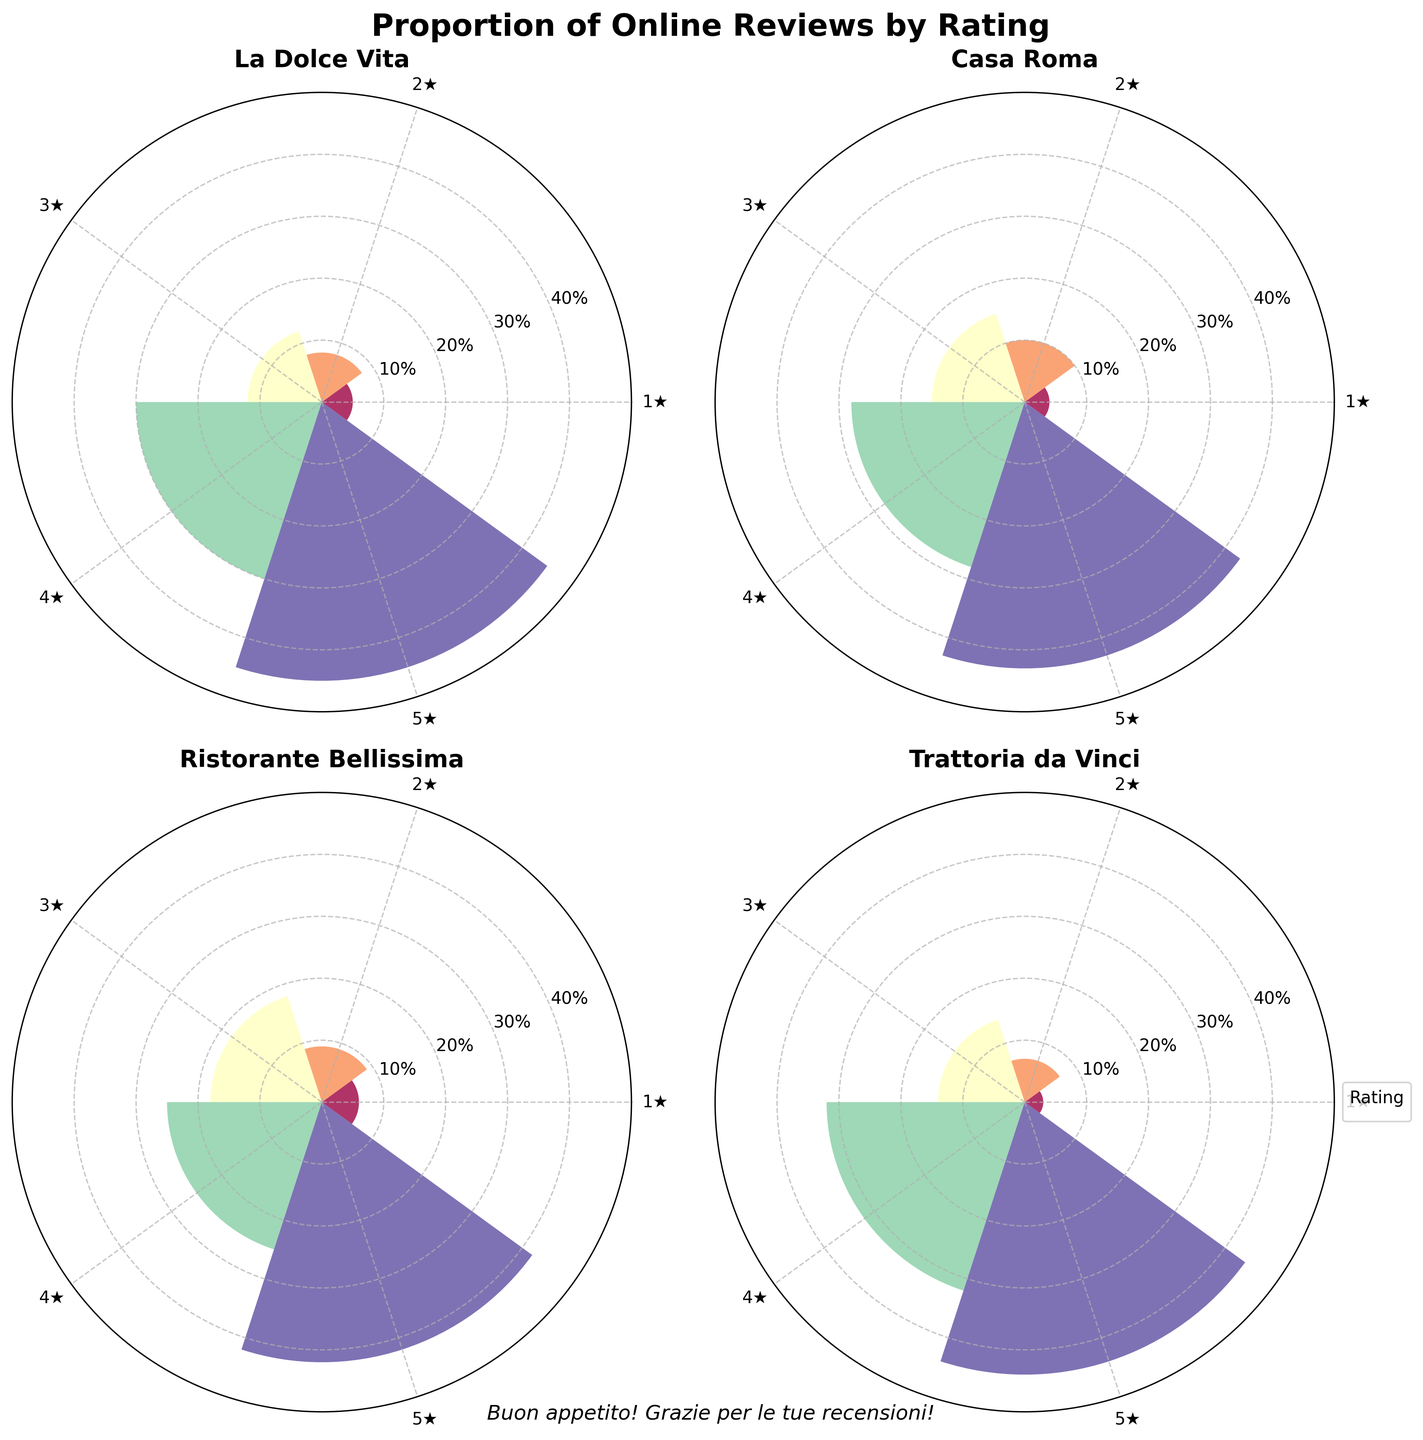Which restaurant has the highest proportion of 5-star reviews? For each restaurant, compare the height of the bar representing 5-star reviews. "La Dolce Vita" has the highest proportion of 5-star reviews at 45%.
Answer: "La Dolce Vita" What is the average proportion of 1-star reviews across all restaurants? Calculate the average by summing the proportions of 1-star reviews from each restaurant (0.05 + 0.04 + 0.06 + 0.03) and divide by the number of restaurants (4). (0.05 + 0.04 + 0.06 + 0.03)/4 = 0.045 or 4.5%.
Answer: 4.5% Which restaurant has the lowest proportion of 4-star reviews? Compare the height of the bars representing 4-star reviews for each restaurant. "Ristorante Bellissima" has the lowest proportion of 4-star reviews at 25%.
Answer: "Ristorante Bellissima" How does the proportion of 2-star reviews in "Casa Roma" compare to the 2-star reviews in "Trattoria da Vinci"? Compare the height of the bars representing 2-star reviews for both restaurants. "Casa Roma" has a 2-star review proportion of 10%, while "Trattoria da Vinci" has 7%.
Answer: "Casa Roma" has a higher proportion What is the combined proportion of 3-star and 4-star reviews for "Ristorante Bellissima"? Add up the proportions for 3-star and 4-star reviews. For "Ristorante Bellissima": 18% (3-star) + 25% (4-star) = 43%.
Answer: 43% Which rating category has the highest average proportion across all restaurants? Calculate the average proportion for each rating category across all restaurants and compare. The 5-star reviews have the highest average: (0.45 + 0.43 + 0.42 + 0.44)/4 = 0.435 or 43.5%.
Answer: 5-star reviews Which restaurant has the most balanced distribution of reviews across all rating categories? Determine which restaurant has the smallest range between the highest and lowest proportions of all rating categories. "Ristorante Bellissima" ranges from 6% (1-star) to 42% (5-star) = 36%. Other restaurants have higher ranges.
Answer: "Ristorante Bellissima" How does the proportion of 5-star reviews in "La Dolce Vita" compare to the proportion of 5-star reviews in "Trattoria da Vinci"? Compare the height of the bars representing 5-star reviews for both restaurants. "La Dolce Vita" has 45%, while "Trattoria da Vinci" has 44%.
Answer: "La Dolce Vita" has a slightly higher proportion What is the sum of the 1-star reviews across all restaurants? Add up the proportions of 1-star reviews from each restaurant: 0.05 + 0.04 + 0.06 + 0.03 = 0.18 or 18%.
Answer: 18% What is the median proportion of 2-star reviews across all restaurants? List the proportions of 2-star reviews in ascending order: 0.07 (Trattoria da Vinci), 0.08 (La Dolce Vita), 0.09 (Ristorante Bellissima), 0.10 (Casa Roma). The median is the average of the two middle values: (0.08 + 0.09)/2 = 0.085 or 8.5%.
Answer: 8.5% 